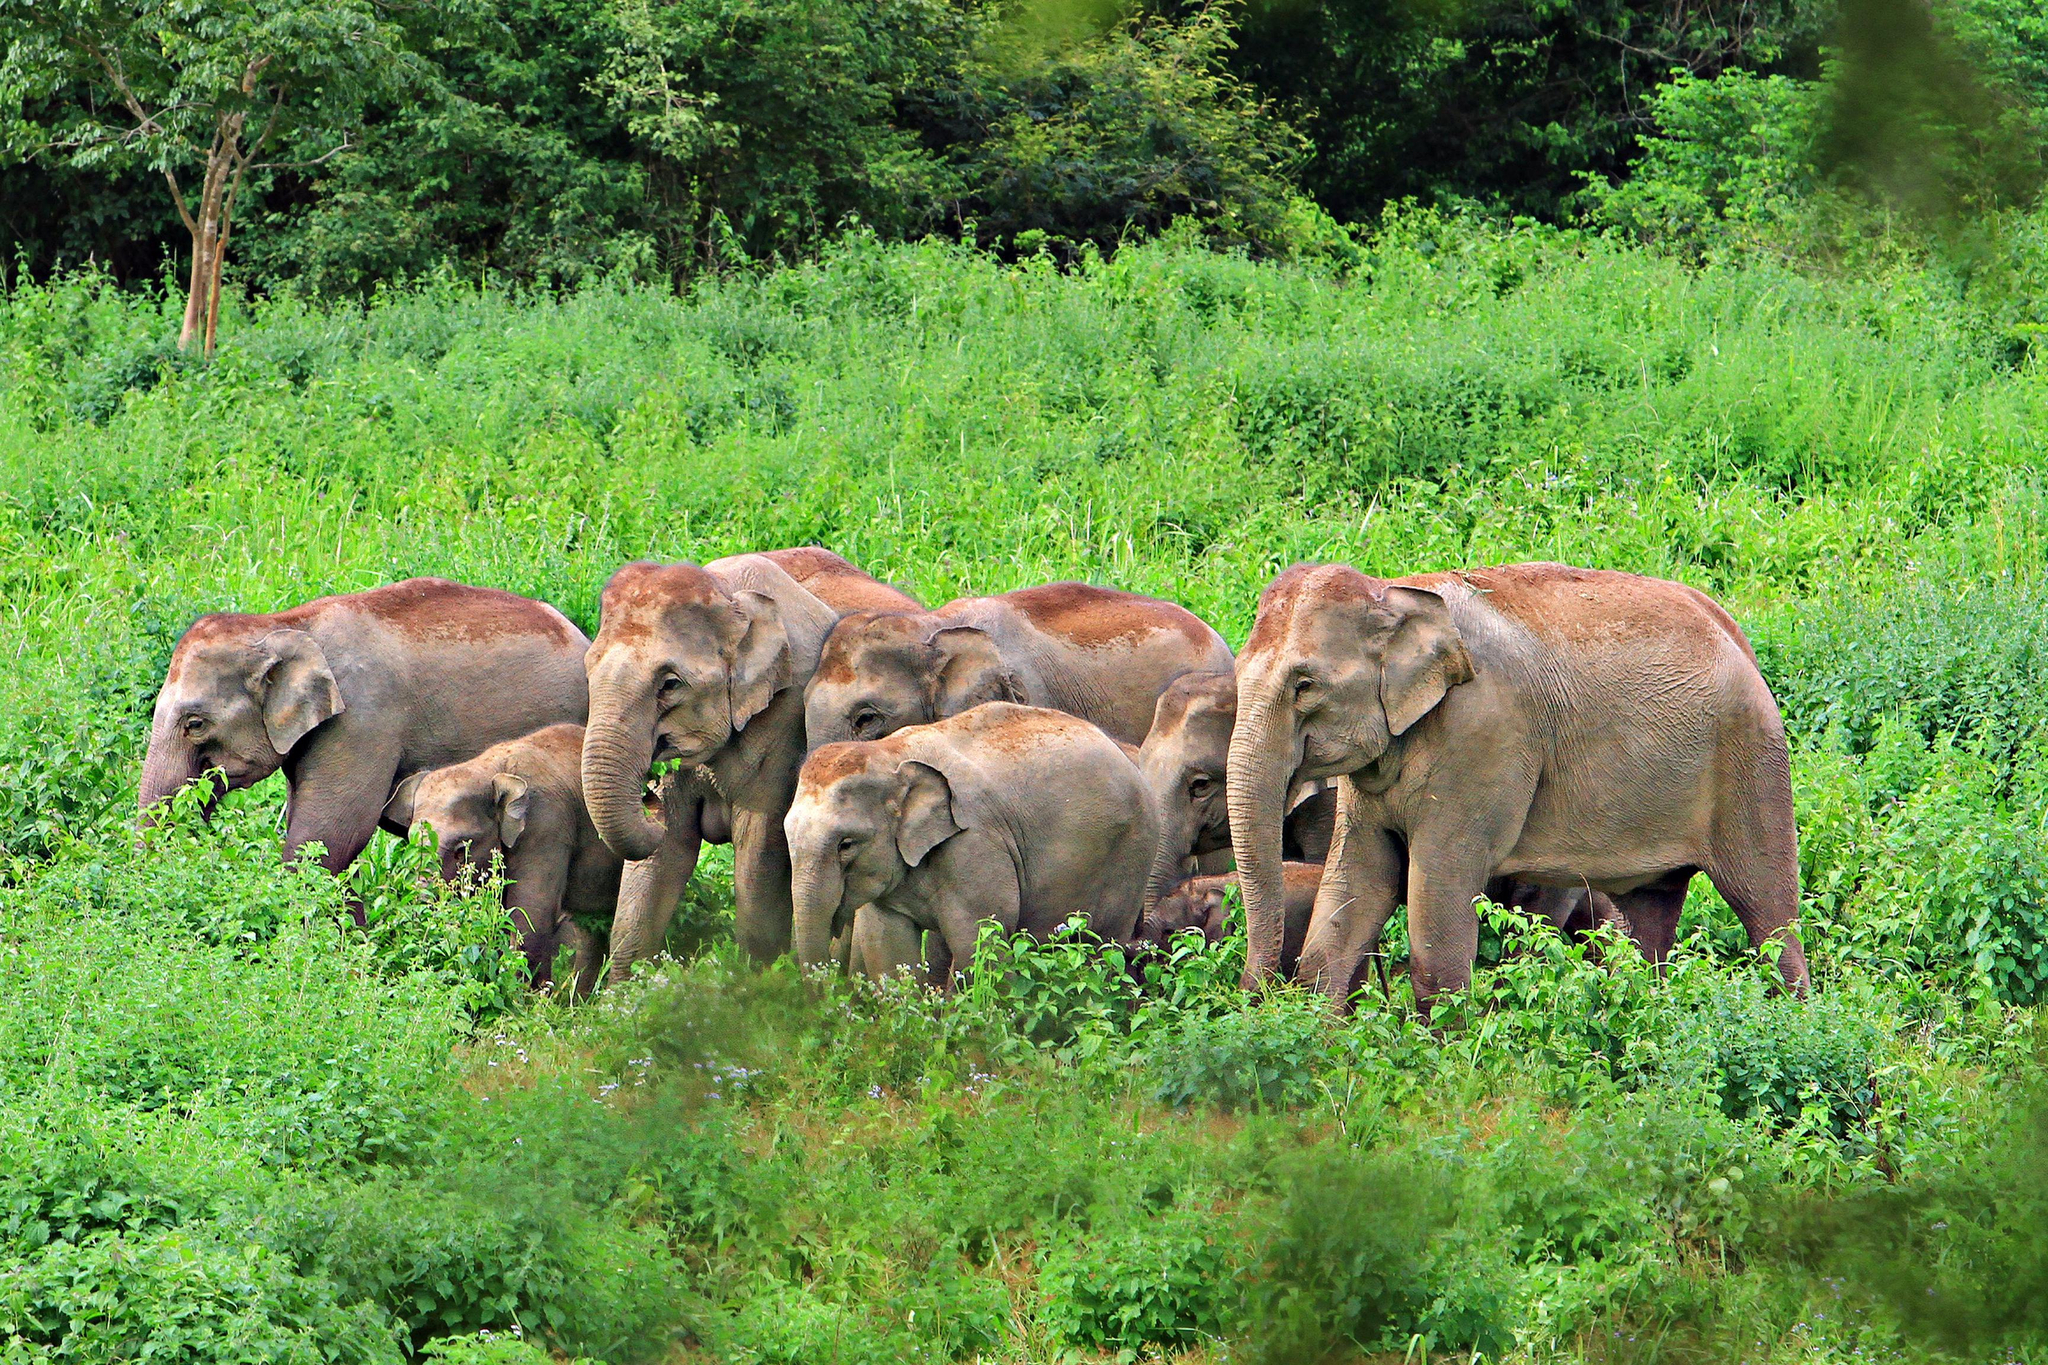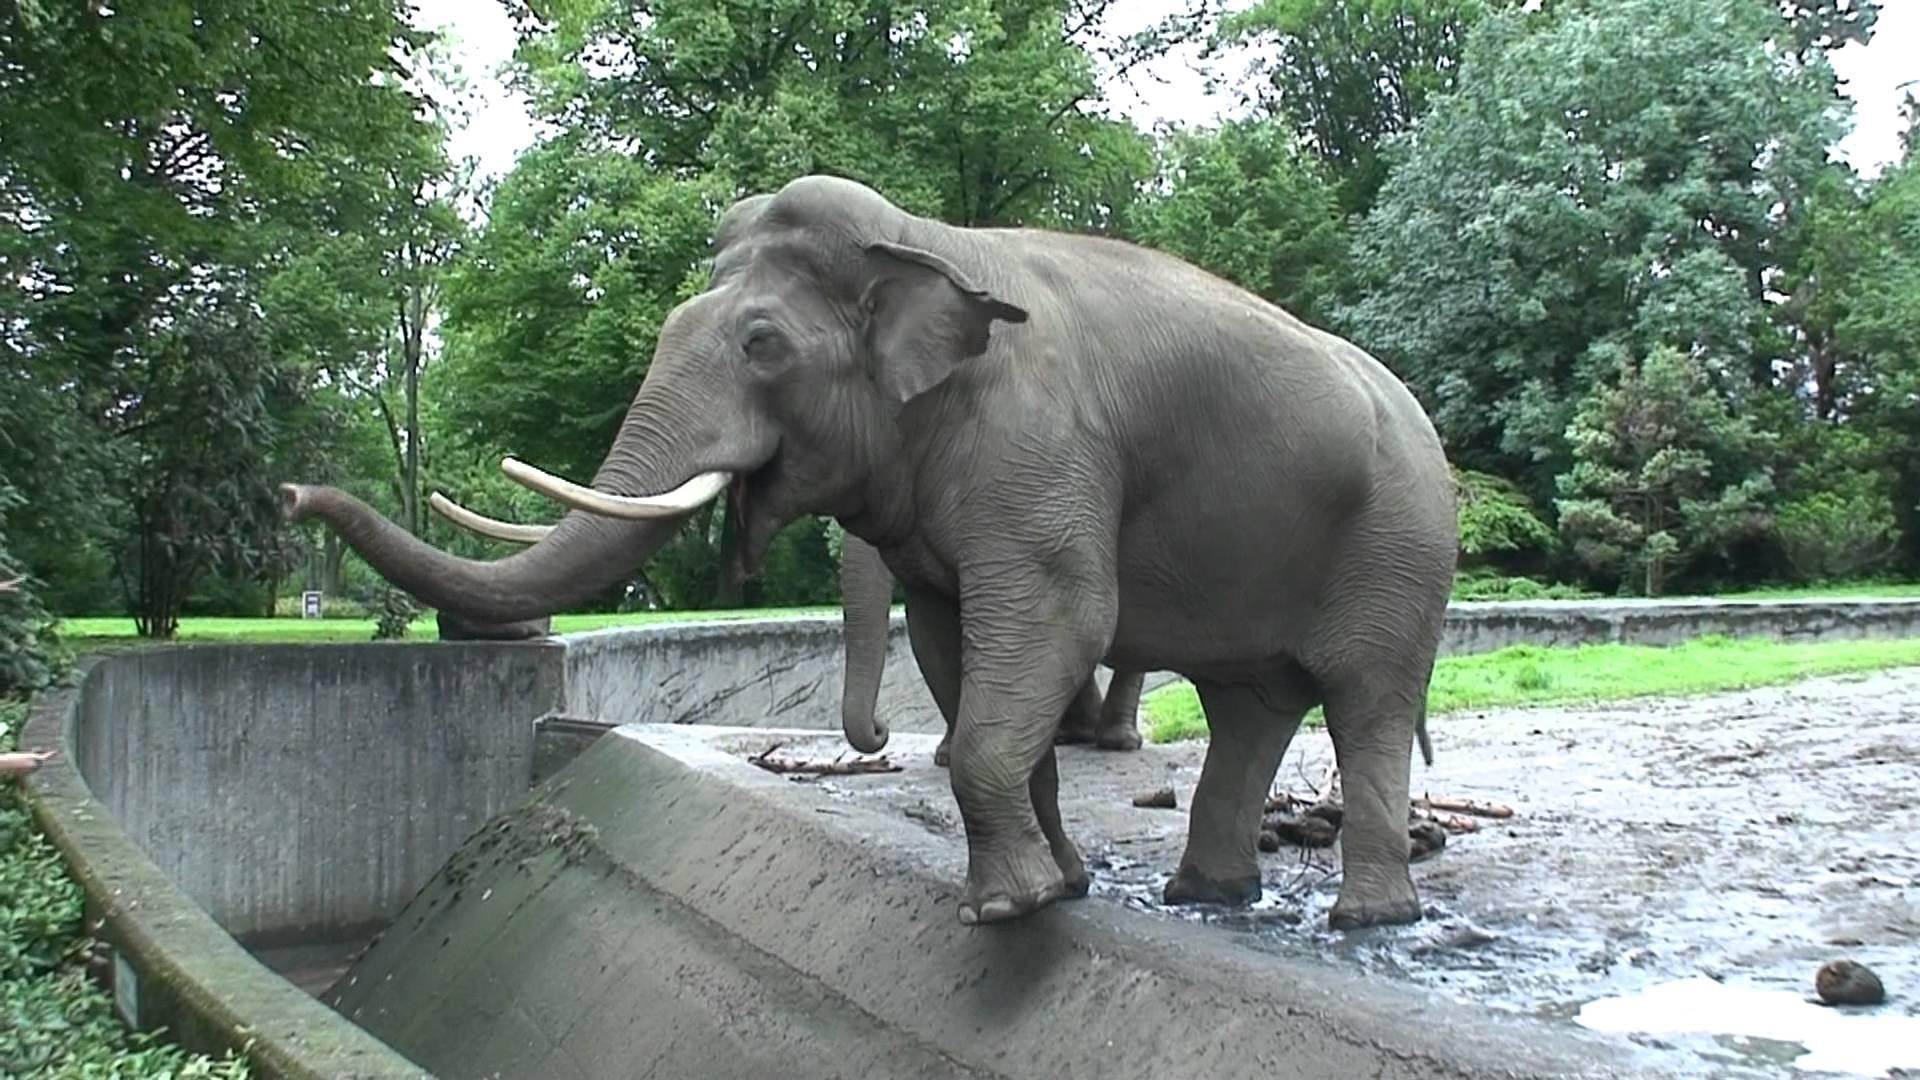The first image is the image on the left, the second image is the image on the right. Examine the images to the left and right. Is the description "An image shows a close group of exactly four elephants and includes animals of different ages." accurate? Answer yes or no. No. The first image is the image on the left, the second image is the image on the right. Given the left and right images, does the statement "There is one elephant in green grass in the image on the left." hold true? Answer yes or no. No. 